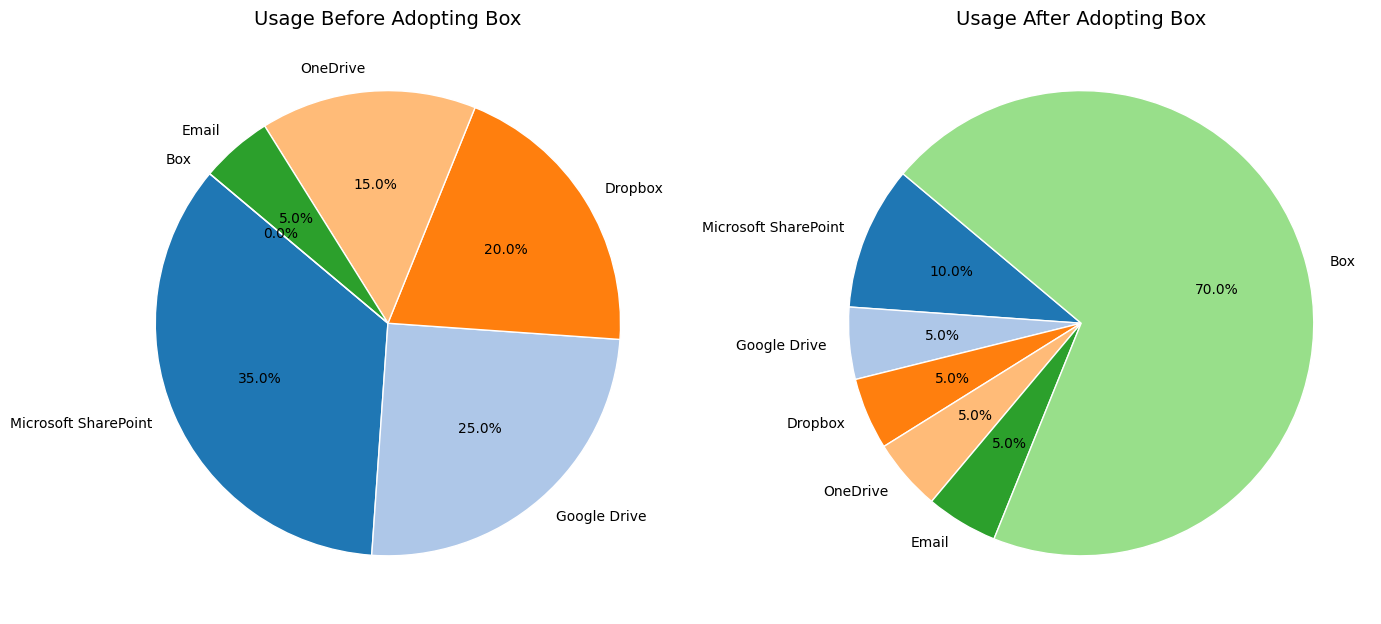Which tool had the highest usage before adopting Box? The pie chart on the left shows the usage of each tool before adopting Box. Microsoft SharePoint has the largest slice of the pie, indicating it had the highest usage.
Answer: Microsoft SharePoint Which tool had the highest increase in usage after adopting Box? Compare the two pie charts, focusing on the difference in usage percentages. Box went from 0% to 70%, which is the largest increase among all tools mentioned.
Answer: Box What is the combined usage percentage of OneDrive and Email after adopting Box? Sum the slices for OneDrive and Email in the "After" pie chart. Both OneDrive and Email have usage percentages of 5% each. The combined usage is 5% + 5% = 10%.
Answer: 10% How did the usage of Google Drive change after adopting Box? Compare the percentage of Google Drive in the "Before" and "After" pie charts. Before adopting Box, Google Drive had 25% usage, and after adopting Box, it went down to 5%. This is a decrease of 20%.
Answer: Decreased by 20% Which tool had the largest decrease in usage after adopting Box? By comparing both pie charts, Microsoft SharePoint decreased from 35% to 10%, resulting in the largest reduction of 25%.
Answer: Microsoft SharePoint What was the total percentage usage of Microsoft SharePoint, Google Drive, and Dropbox before adopting Box? Add the usage percentages of Microsoft SharePoint (35%), Google Drive (25%), and Dropbox (20%) from the "Before" pie chart. The total is 35% + 25% + 20% = 80%.
Answer: 80% What is the difference in usage percentage between Dropbox before and after adopting Box? Compare the usage percentages of Dropbox in the "Before" and "After" charts. Dropbox had 20% usage before and 5% usage after, resulting in a difference of 20% - 5% = 15%.
Answer: 15% How did the usage of OneDrive change after adopting Box? Compare the usage of OneDrive in both pie charts. Before adopting Box, OneDrive usage was 15%, and after adopting Box, it dropped to 5%. This is a decrease of 10%.
Answer: Decreased by 10% Which tools were equally used after adopting Box? Look at the "After" pie chart and identify the tools with equal slices. Google Drive, Dropbox, OneDrive, and Email each have a 5% usage rate.
Answer: Google Drive, Dropbox, OneDrive, and Email 